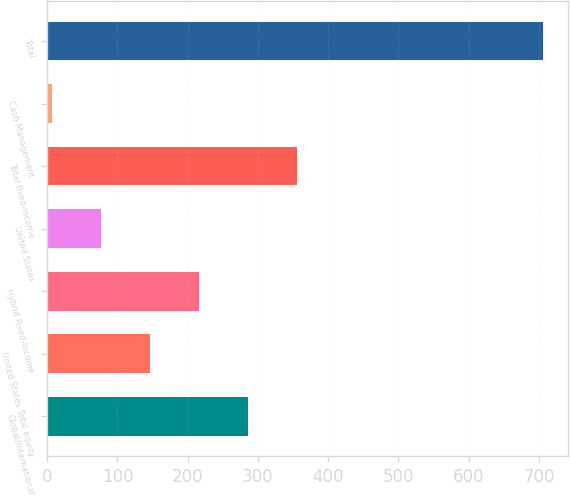Convert chart. <chart><loc_0><loc_0><loc_500><loc_500><bar_chart><fcel>Global/international<fcel>United States Total equity<fcel>Hybrid Fixed-Income<fcel>United States<fcel>Total fixed-income<fcel>Cash Management<fcel>Total<nl><fcel>286.06<fcel>146.18<fcel>216.12<fcel>76.24<fcel>356<fcel>6.3<fcel>705.7<nl></chart> 